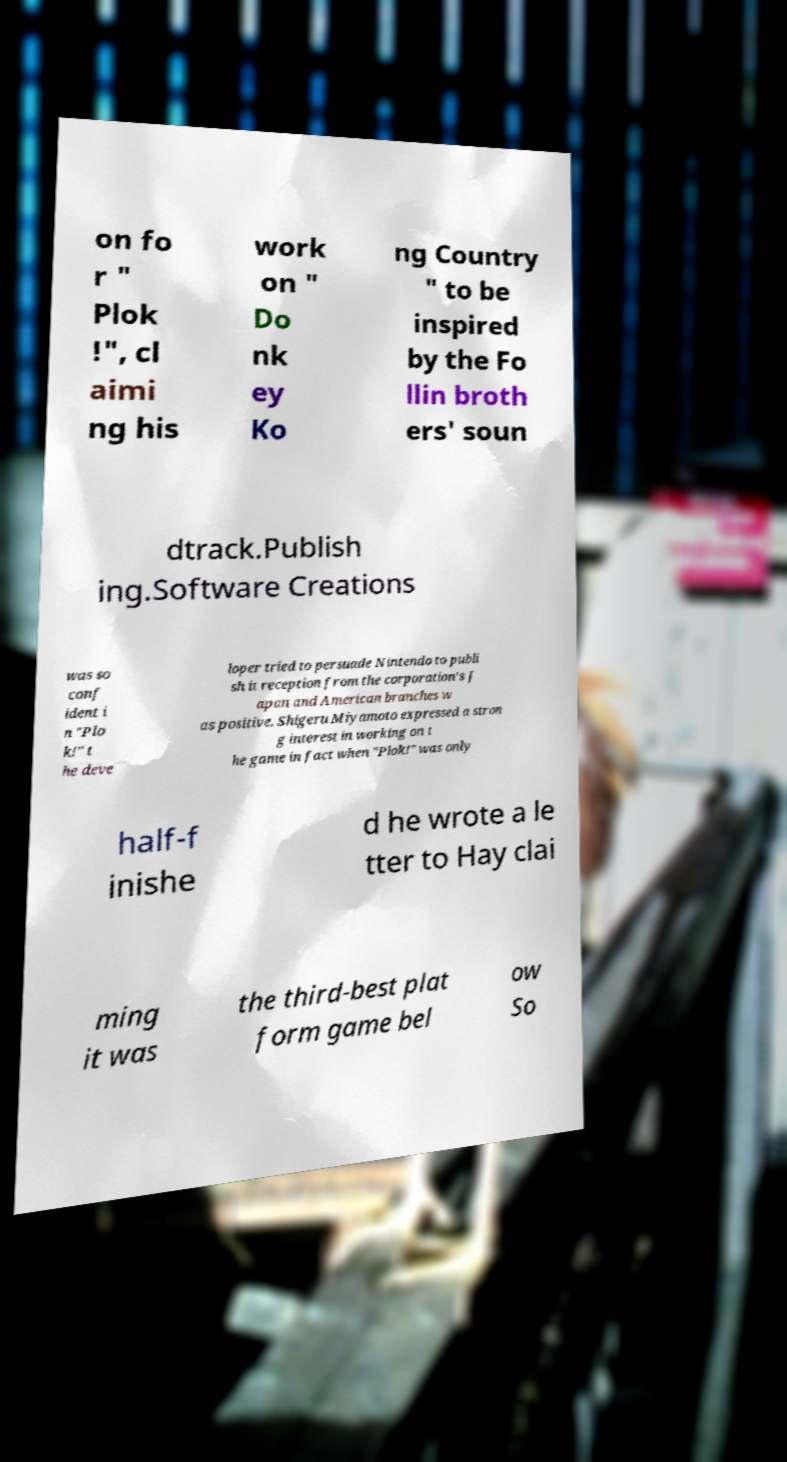For documentation purposes, I need the text within this image transcribed. Could you provide that? on fo r " Plok !", cl aimi ng his work on " Do nk ey Ko ng Country " to be inspired by the Fo llin broth ers' soun dtrack.Publish ing.Software Creations was so conf ident i n "Plo k!" t he deve loper tried to persuade Nintendo to publi sh it reception from the corporation's J apan and American branches w as positive. Shigeru Miyamoto expressed a stron g interest in working on t he game in fact when "Plok!" was only half-f inishe d he wrote a le tter to Hay clai ming it was the third-best plat form game bel ow So 